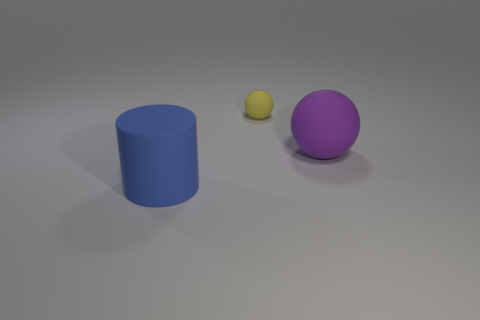How many objects are there in total in the image? In the image, there are three distinct objects: a blue cylinder, a small yellow ball, and a larger purple sphere. 